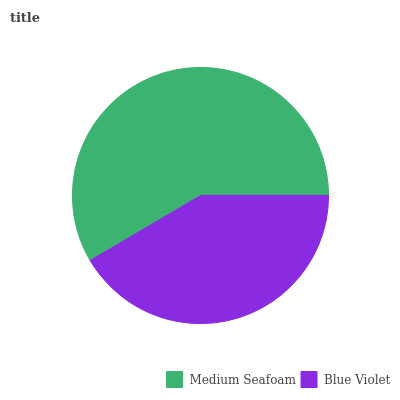Is Blue Violet the minimum?
Answer yes or no. Yes. Is Medium Seafoam the maximum?
Answer yes or no. Yes. Is Blue Violet the maximum?
Answer yes or no. No. Is Medium Seafoam greater than Blue Violet?
Answer yes or no. Yes. Is Blue Violet less than Medium Seafoam?
Answer yes or no. Yes. Is Blue Violet greater than Medium Seafoam?
Answer yes or no. No. Is Medium Seafoam less than Blue Violet?
Answer yes or no. No. Is Medium Seafoam the high median?
Answer yes or no. Yes. Is Blue Violet the low median?
Answer yes or no. Yes. Is Blue Violet the high median?
Answer yes or no. No. Is Medium Seafoam the low median?
Answer yes or no. No. 